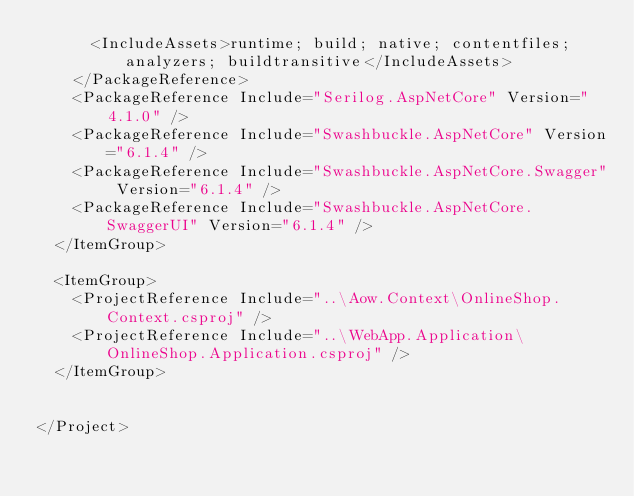<code> <loc_0><loc_0><loc_500><loc_500><_XML_>      <IncludeAssets>runtime; build; native; contentfiles; analyzers; buildtransitive</IncludeAssets>
    </PackageReference>
    <PackageReference Include="Serilog.AspNetCore" Version="4.1.0" />
    <PackageReference Include="Swashbuckle.AspNetCore" Version="6.1.4" />
    <PackageReference Include="Swashbuckle.AspNetCore.Swagger" Version="6.1.4" />
    <PackageReference Include="Swashbuckle.AspNetCore.SwaggerUI" Version="6.1.4" />
  </ItemGroup>

  <ItemGroup>
    <ProjectReference Include="..\Aow.Context\OnlineShop.Context.csproj" />
    <ProjectReference Include="..\WebApp.Application\OnlineShop.Application.csproj" />
  </ItemGroup>


</Project>
</code> 